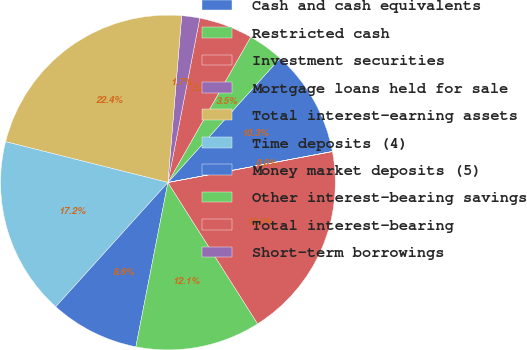<chart> <loc_0><loc_0><loc_500><loc_500><pie_chart><fcel>Cash and cash equivalents<fcel>Restricted cash<fcel>Investment securities<fcel>Mortgage loans held for sale<fcel>Total interest-earning assets<fcel>Time deposits (4)<fcel>Money market deposits (5)<fcel>Other interest-bearing savings<fcel>Total interest-bearing<fcel>Short-term borrowings<nl><fcel>10.34%<fcel>3.46%<fcel>5.18%<fcel>1.74%<fcel>22.39%<fcel>17.23%<fcel>8.62%<fcel>12.07%<fcel>18.95%<fcel>0.02%<nl></chart> 